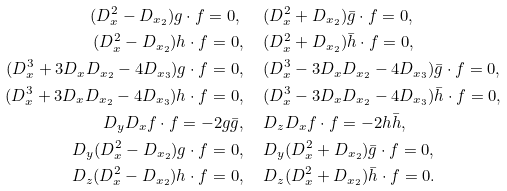Convert formula to latex. <formula><loc_0><loc_0><loc_500><loc_500>( D _ { x } ^ { 2 } - D _ { x _ { 2 } } ) g \cdot f = 0 , \ & \quad ( D _ { x } ^ { 2 } + D _ { x _ { 2 } } ) \bar { g } \cdot f = 0 , \\ ( D _ { x } ^ { 2 } - D _ { x _ { 2 } } ) h \cdot f = 0 , \ & \quad ( D _ { x } ^ { 2 } + D _ { x _ { 2 } } ) \bar { h } \cdot f = 0 , \\ ( D _ { x } ^ { 3 } + 3 D _ { x } D _ { x _ { 2 } } - 4 D _ { x _ { 3 } } ) g \cdot f = 0 , \ & \quad ( D _ { x } ^ { 3 } - 3 D _ { x } D _ { x _ { 2 } } - 4 D _ { x _ { 3 } } ) \bar { g } \cdot f = 0 , \\ ( D _ { x } ^ { 3 } + 3 D _ { x } D _ { x _ { 2 } } - 4 D _ { x _ { 3 } } ) h \cdot f = 0 , \ & \quad ( D _ { x } ^ { 3 } - 3 D _ { x } D _ { x _ { 2 } } - 4 D _ { x _ { 3 } } ) \bar { h } \cdot f = 0 , \\ D _ { y } D _ { x } f \cdot f = - 2 g \bar { g } , \ & \quad D _ { z } D _ { x } f \cdot f = - 2 h \bar { h } , \\ D _ { y } ( D _ { x } ^ { 2 } - D _ { x _ { 2 } } ) g \cdot f = 0 , \ & \quad D _ { y } ( D _ { x } ^ { 2 } + D _ { x _ { 2 } } ) \bar { g } \cdot f = 0 , \\ D _ { z } ( D _ { x } ^ { 2 } - D _ { x _ { 2 } } ) h \cdot f = 0 , \ & \quad D _ { z } ( D _ { x } ^ { 2 } + D _ { x _ { 2 } } ) \bar { h } \cdot f = 0 .</formula> 